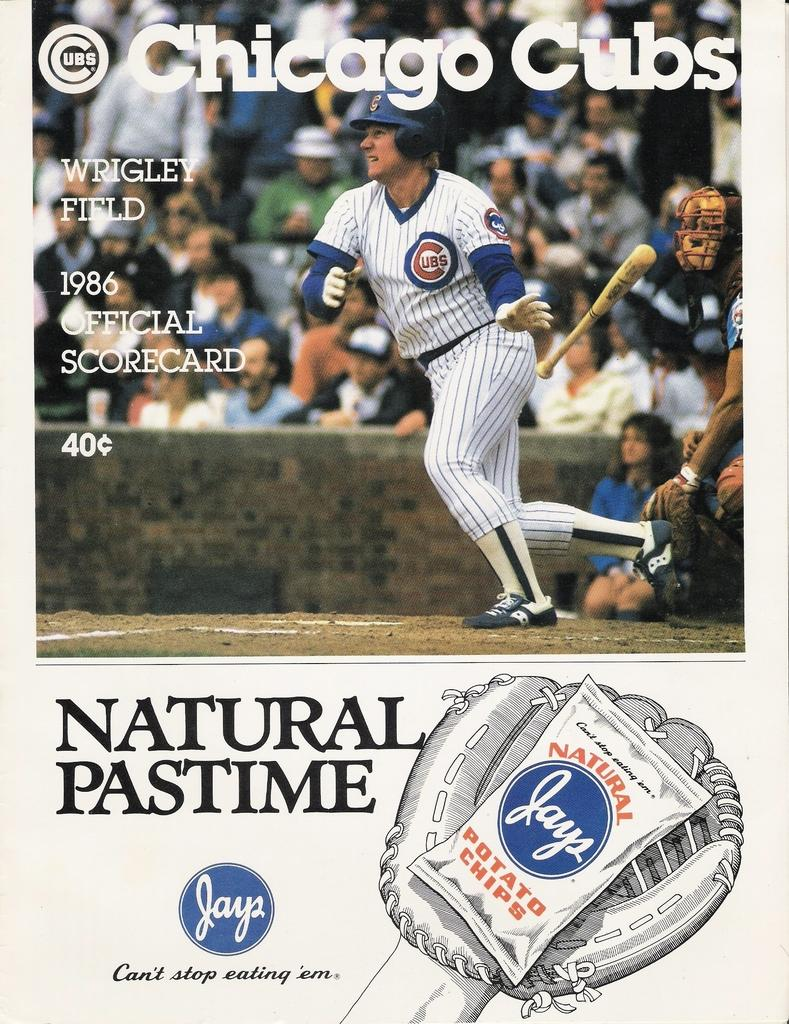<image>
Offer a succinct explanation of the picture presented. a Chicago Cubs logo that is on a jersey 